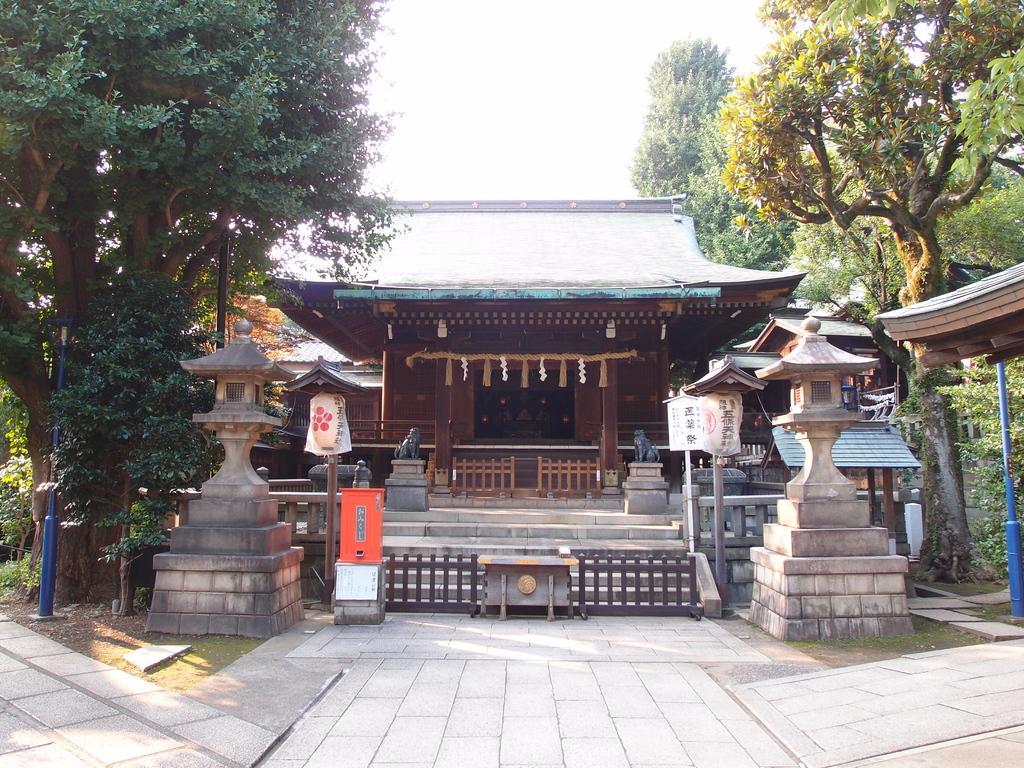Can you describe this image briefly? In this image I can see the building , few trees, few poles, the railing, few boards and the road. In the background I can see few trees and the sky. 